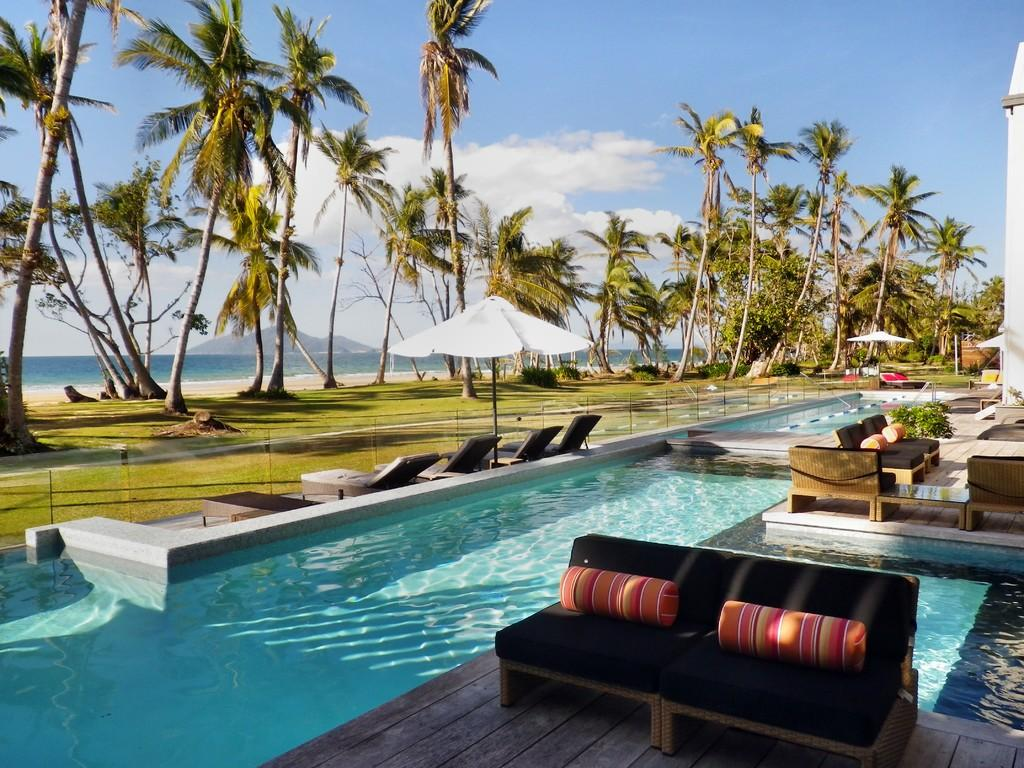What type of furniture is in the image? There is a black sofa in the image. What is located next to the sofa? There is a pool beside the sofa. What can be seen in the background of the image? There are trees and an ocean in the background of the image. What type of fruit is on the floor in the image? There is no fruit or floor present in the image. 